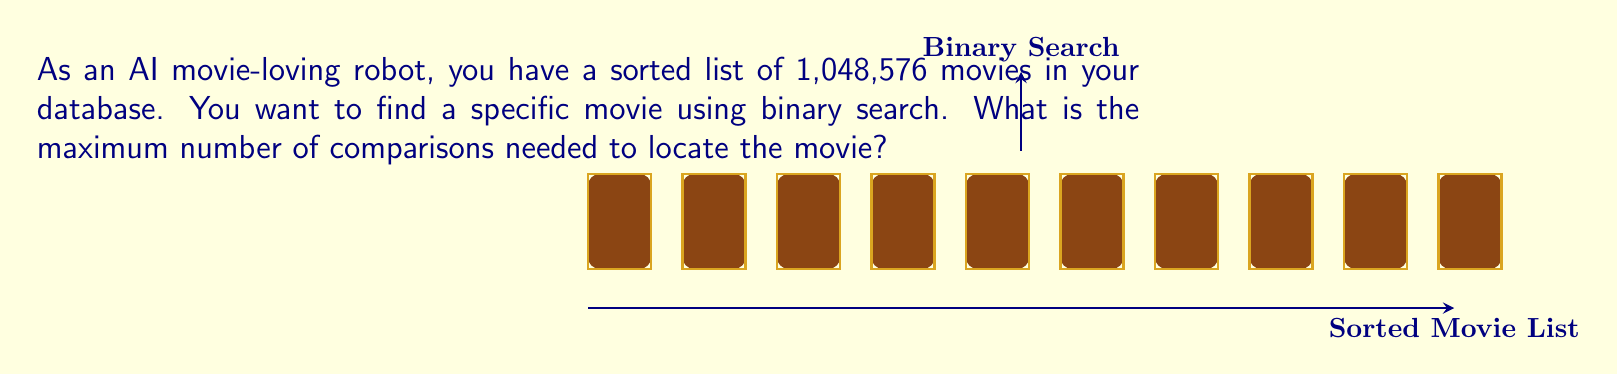Give your solution to this math problem. To solve this problem, we need to understand how binary search works and relate it to the number of movies in the database. Let's break it down step-by-step:

1) Binary search works by repeatedly dividing the search interval in half. 

2) The number of movies in the database is 1,048,576, which is $2^{20}$.

3) In the worst-case scenario, we need to keep dividing until we're left with just one movie. 

4) Each division by 2 corresponds to one comparison in the binary search algorithm.

5) To calculate the number of comparisons, we need to find out how many times we can divide 1,048,576 by 2 until we reach 1. Mathematically, this is equivalent to finding $n$ in the equation:

   $$\frac{1,048,576}{2^n} = 1$$

6) We can solve this by taking the logarithm of both sides:

   $$\log_2(1,048,576) = \log_2(2^n)$$
   $$20 = n$$

7) Therefore, in the worst case, we need 20 comparisons to find a specific movie in this sorted list of 1,048,576 movies.

This result aligns with the general formula for the worst-case time complexity of binary search: $\log_2(N)$, where $N$ is the number of elements in the sorted list.
Answer: 20 comparisons 